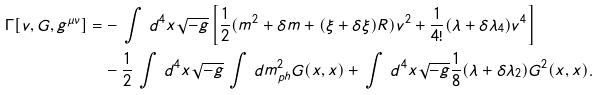<formula> <loc_0><loc_0><loc_500><loc_500>\Gamma [ v , G , g ^ { \mu \nu } ] = & - \, \int \, d ^ { 4 } x \sqrt { - g } \left [ \frac { 1 } { 2 } ( m ^ { 2 } + \delta m + ( \xi + \delta \xi ) R ) v ^ { 2 } + \frac { 1 } { 4 ! } ( \lambda + \delta \lambda _ { 4 } ) v ^ { 4 } \right ] \\ & - \frac { 1 } { 2 } \, \int \, d ^ { 4 } x \sqrt { - g } \, \int \, d m _ { p h } ^ { 2 } G ( x , x ) + \, \int \, d ^ { 4 } x \sqrt { - g } \frac { 1 } { 8 } ( \lambda + \delta \lambda _ { 2 } ) G ^ { 2 } ( x , x ) .</formula> 